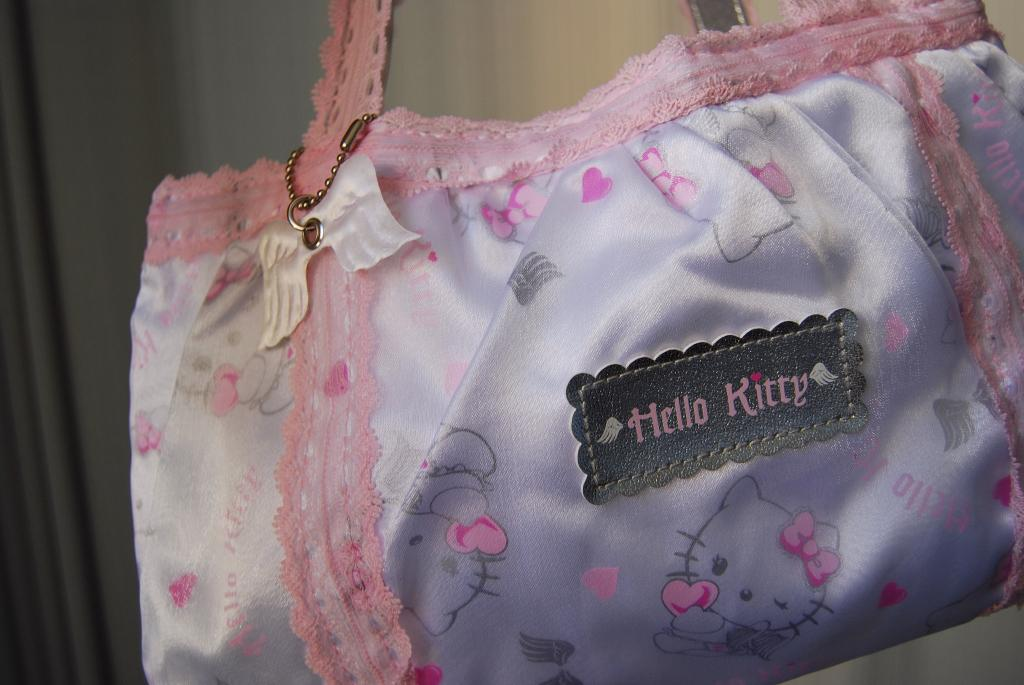What object is present in the image? There is a bag in the image. Can you describe the appearance of the bag? The bag is white and pink in color, and it has Hello Kitty symbols on it. What is written on the bag? The text "Hello Kitty" is written on the bag. How does the bag drain water in the image? The bag does not drain water in the image, as it is not a drain or a water-related object. 